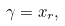<formula> <loc_0><loc_0><loc_500><loc_500>\gamma = x _ { r } ,</formula> 